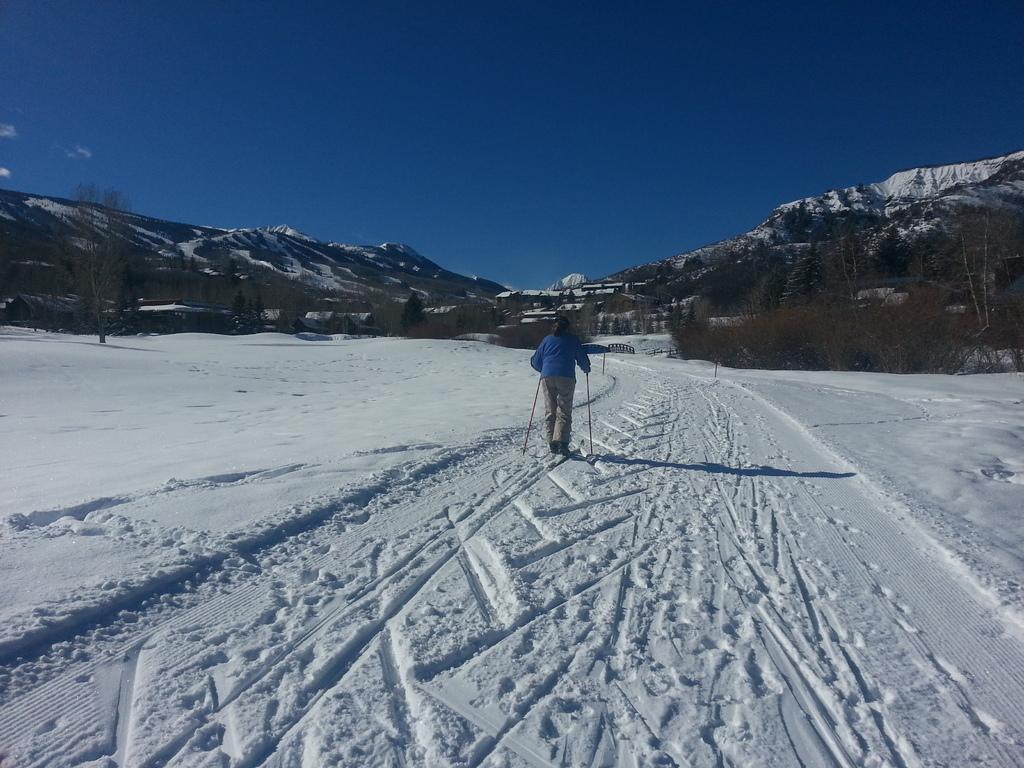In one or two sentences, can you explain what this image depicts? This picture is clicked outside the city. In the center we can see a person seems to be skiing on a ski-boards and we can see there is a lot of snow. In the background we can see the sky, hills, trees and plants and some other objects. 